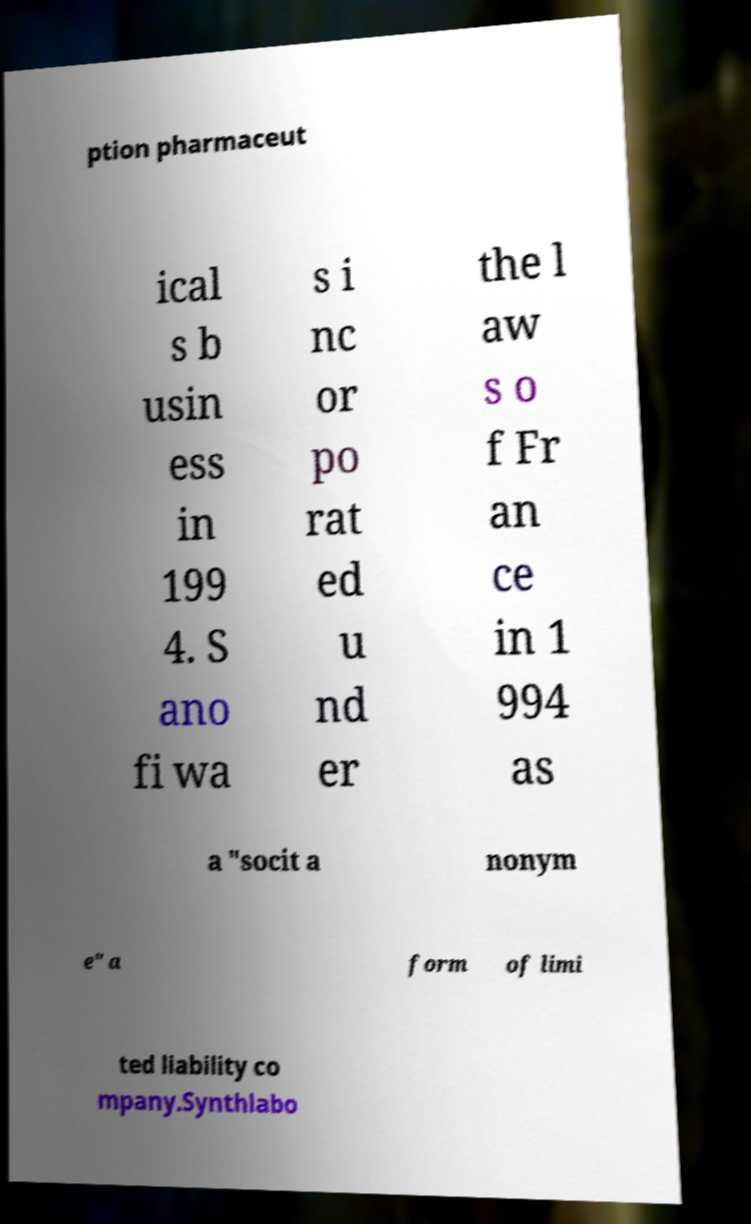I need the written content from this picture converted into text. Can you do that? ption pharmaceut ical s b usin ess in 199 4. S ano fi wa s i nc or po rat ed u nd er the l aw s o f Fr an ce in 1 994 as a "socit a nonym e" a form of limi ted liability co mpany.Synthlabo 